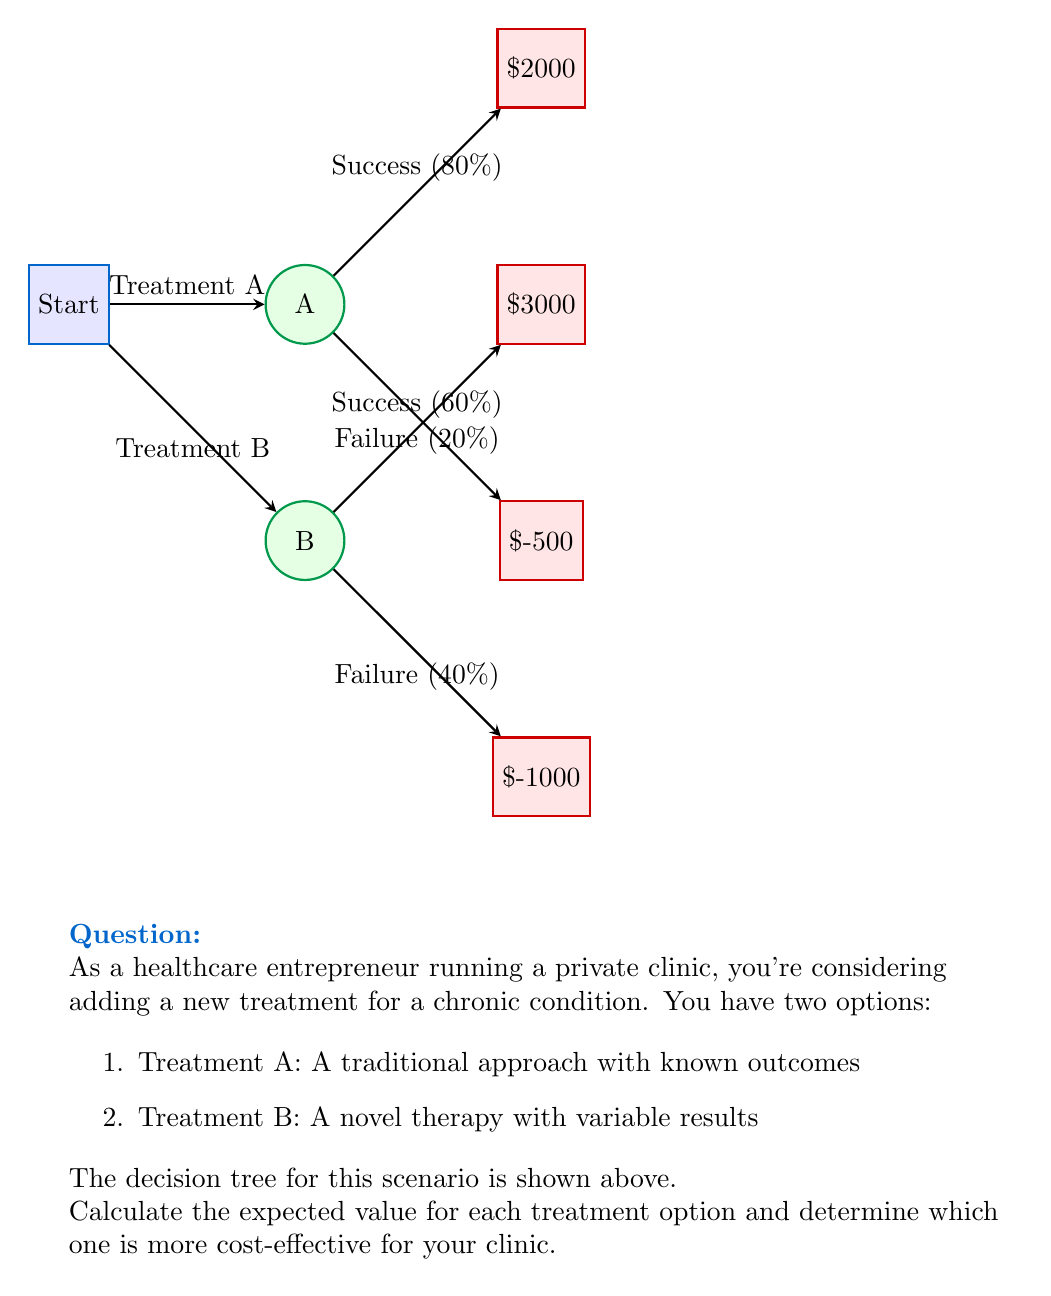Show me your answer to this math problem. Let's approach this step-by-step:

1) For Treatment A:
   - Probability of success = 80% = 0.8
   - Probability of failure = 20% = 0.2
   - Profit for success = $2000
   - Loss for failure = $-500

   Expected Value of Treatment A:
   $$EV(A) = 0.8 \times 2000 + 0.2 \times (-500) = 1600 - 100 = 1500$$

2) For Treatment B:
   - Probability of success = 60% = 0.6
   - Probability of failure = 40% = 0.4
   - Profit for success = $3000
   - Loss for failure = $-1000

   Expected Value of Treatment B:
   $$EV(B) = 0.6 \times 3000 + 0.4 \times (-1000) = 1800 - 400 = 1400$$

3) Comparing the expected values:
   Treatment A: $1500
   Treatment B: $1400

   The difference is:
   $$1500 - 1400 = 100$$

Therefore, Treatment A has a higher expected value by $100.
Answer: Treatment A is more cost-effective with an expected value of $1500, which is $100 higher than Treatment B. 